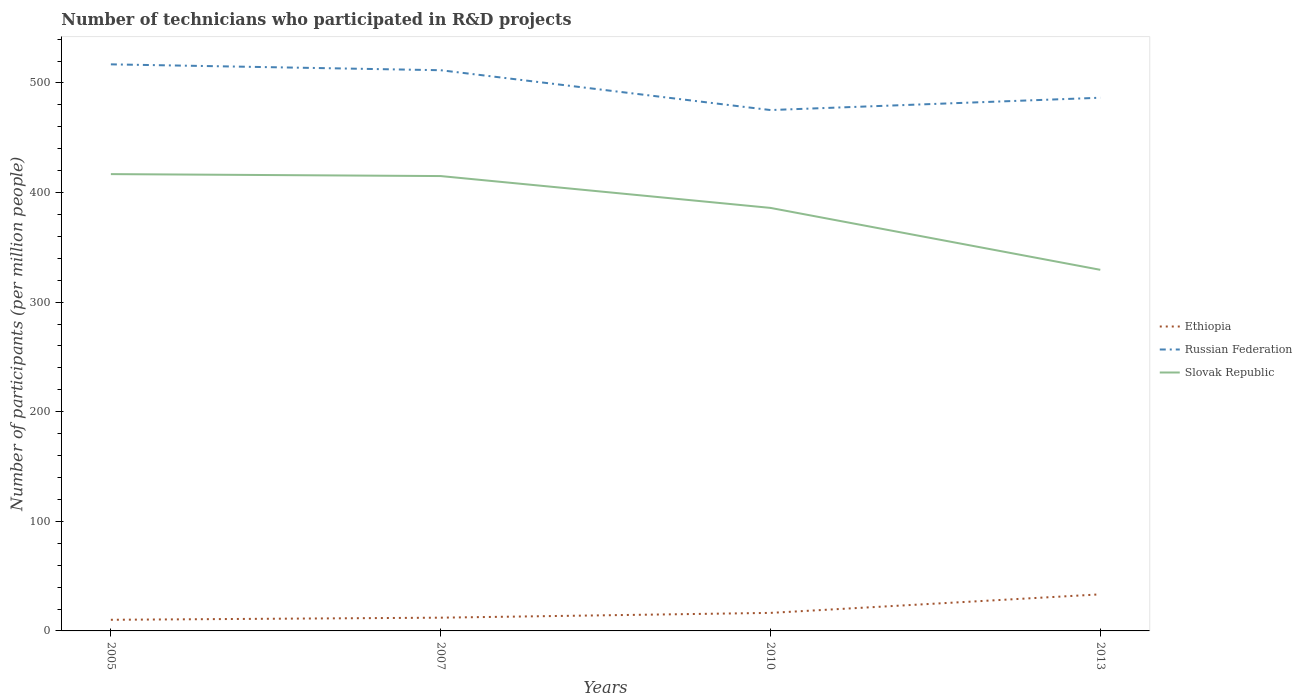Does the line corresponding to Ethiopia intersect with the line corresponding to Russian Federation?
Offer a terse response. No. Across all years, what is the maximum number of technicians who participated in R&D projects in Russian Federation?
Give a very brief answer. 475.29. In which year was the number of technicians who participated in R&D projects in Ethiopia maximum?
Give a very brief answer. 2005. What is the total number of technicians who participated in R&D projects in Slovak Republic in the graph?
Provide a succinct answer. 29.05. What is the difference between the highest and the second highest number of technicians who participated in R&D projects in Ethiopia?
Offer a very short reply. 23.21. What is the difference between the highest and the lowest number of technicians who participated in R&D projects in Slovak Republic?
Give a very brief answer. 2. Is the number of technicians who participated in R&D projects in Ethiopia strictly greater than the number of technicians who participated in R&D projects in Russian Federation over the years?
Ensure brevity in your answer.  Yes. How many lines are there?
Your response must be concise. 3. Where does the legend appear in the graph?
Offer a very short reply. Center right. How are the legend labels stacked?
Your answer should be very brief. Vertical. What is the title of the graph?
Your answer should be compact. Number of technicians who participated in R&D projects. What is the label or title of the X-axis?
Your response must be concise. Years. What is the label or title of the Y-axis?
Offer a very short reply. Number of participants (per million people). What is the Number of participants (per million people) of Ethiopia in 2005?
Provide a short and direct response. 10.17. What is the Number of participants (per million people) in Russian Federation in 2005?
Provide a short and direct response. 517. What is the Number of participants (per million people) in Slovak Republic in 2005?
Provide a succinct answer. 416.85. What is the Number of participants (per million people) of Ethiopia in 2007?
Provide a short and direct response. 12.09. What is the Number of participants (per million people) in Russian Federation in 2007?
Provide a short and direct response. 511.64. What is the Number of participants (per million people) in Slovak Republic in 2007?
Offer a terse response. 415.06. What is the Number of participants (per million people) of Ethiopia in 2010?
Offer a terse response. 16.46. What is the Number of participants (per million people) in Russian Federation in 2010?
Your response must be concise. 475.29. What is the Number of participants (per million people) in Slovak Republic in 2010?
Your answer should be very brief. 386.01. What is the Number of participants (per million people) in Ethiopia in 2013?
Provide a succinct answer. 33.38. What is the Number of participants (per million people) in Russian Federation in 2013?
Make the answer very short. 486.54. What is the Number of participants (per million people) in Slovak Republic in 2013?
Make the answer very short. 329.51. Across all years, what is the maximum Number of participants (per million people) of Ethiopia?
Provide a short and direct response. 33.38. Across all years, what is the maximum Number of participants (per million people) of Russian Federation?
Ensure brevity in your answer.  517. Across all years, what is the maximum Number of participants (per million people) of Slovak Republic?
Your answer should be compact. 416.85. Across all years, what is the minimum Number of participants (per million people) of Ethiopia?
Give a very brief answer. 10.17. Across all years, what is the minimum Number of participants (per million people) in Russian Federation?
Your answer should be compact. 475.29. Across all years, what is the minimum Number of participants (per million people) of Slovak Republic?
Your answer should be compact. 329.51. What is the total Number of participants (per million people) of Ethiopia in the graph?
Make the answer very short. 72.1. What is the total Number of participants (per million people) of Russian Federation in the graph?
Make the answer very short. 1990.48. What is the total Number of participants (per million people) in Slovak Republic in the graph?
Your answer should be compact. 1547.42. What is the difference between the Number of participants (per million people) in Ethiopia in 2005 and that in 2007?
Ensure brevity in your answer.  -1.92. What is the difference between the Number of participants (per million people) in Russian Federation in 2005 and that in 2007?
Your answer should be compact. 5.36. What is the difference between the Number of participants (per million people) in Slovak Republic in 2005 and that in 2007?
Your answer should be compact. 1.79. What is the difference between the Number of participants (per million people) in Ethiopia in 2005 and that in 2010?
Provide a succinct answer. -6.29. What is the difference between the Number of participants (per million people) of Russian Federation in 2005 and that in 2010?
Offer a terse response. 41.71. What is the difference between the Number of participants (per million people) of Slovak Republic in 2005 and that in 2010?
Make the answer very short. 30.84. What is the difference between the Number of participants (per million people) in Ethiopia in 2005 and that in 2013?
Give a very brief answer. -23.21. What is the difference between the Number of participants (per million people) in Russian Federation in 2005 and that in 2013?
Your answer should be compact. 30.46. What is the difference between the Number of participants (per million people) in Slovak Republic in 2005 and that in 2013?
Offer a very short reply. 87.34. What is the difference between the Number of participants (per million people) in Ethiopia in 2007 and that in 2010?
Your response must be concise. -4.37. What is the difference between the Number of participants (per million people) of Russian Federation in 2007 and that in 2010?
Make the answer very short. 36.35. What is the difference between the Number of participants (per million people) in Slovak Republic in 2007 and that in 2010?
Your response must be concise. 29.05. What is the difference between the Number of participants (per million people) in Ethiopia in 2007 and that in 2013?
Ensure brevity in your answer.  -21.29. What is the difference between the Number of participants (per million people) of Russian Federation in 2007 and that in 2013?
Your response must be concise. 25.1. What is the difference between the Number of participants (per million people) of Slovak Republic in 2007 and that in 2013?
Make the answer very short. 85.55. What is the difference between the Number of participants (per million people) in Ethiopia in 2010 and that in 2013?
Keep it short and to the point. -16.93. What is the difference between the Number of participants (per million people) in Russian Federation in 2010 and that in 2013?
Ensure brevity in your answer.  -11.25. What is the difference between the Number of participants (per million people) of Slovak Republic in 2010 and that in 2013?
Provide a short and direct response. 56.5. What is the difference between the Number of participants (per million people) of Ethiopia in 2005 and the Number of participants (per million people) of Russian Federation in 2007?
Your answer should be very brief. -501.47. What is the difference between the Number of participants (per million people) in Ethiopia in 2005 and the Number of participants (per million people) in Slovak Republic in 2007?
Offer a very short reply. -404.89. What is the difference between the Number of participants (per million people) of Russian Federation in 2005 and the Number of participants (per million people) of Slovak Republic in 2007?
Your response must be concise. 101.94. What is the difference between the Number of participants (per million people) in Ethiopia in 2005 and the Number of participants (per million people) in Russian Federation in 2010?
Provide a short and direct response. -465.12. What is the difference between the Number of participants (per million people) in Ethiopia in 2005 and the Number of participants (per million people) in Slovak Republic in 2010?
Your answer should be compact. -375.84. What is the difference between the Number of participants (per million people) of Russian Federation in 2005 and the Number of participants (per million people) of Slovak Republic in 2010?
Provide a short and direct response. 130.99. What is the difference between the Number of participants (per million people) of Ethiopia in 2005 and the Number of participants (per million people) of Russian Federation in 2013?
Provide a succinct answer. -476.37. What is the difference between the Number of participants (per million people) of Ethiopia in 2005 and the Number of participants (per million people) of Slovak Republic in 2013?
Offer a terse response. -319.34. What is the difference between the Number of participants (per million people) in Russian Federation in 2005 and the Number of participants (per million people) in Slovak Republic in 2013?
Offer a very short reply. 187.49. What is the difference between the Number of participants (per million people) in Ethiopia in 2007 and the Number of participants (per million people) in Russian Federation in 2010?
Your answer should be compact. -463.2. What is the difference between the Number of participants (per million people) of Ethiopia in 2007 and the Number of participants (per million people) of Slovak Republic in 2010?
Offer a terse response. -373.92. What is the difference between the Number of participants (per million people) in Russian Federation in 2007 and the Number of participants (per million people) in Slovak Republic in 2010?
Make the answer very short. 125.63. What is the difference between the Number of participants (per million people) in Ethiopia in 2007 and the Number of participants (per million people) in Russian Federation in 2013?
Ensure brevity in your answer.  -474.45. What is the difference between the Number of participants (per million people) of Ethiopia in 2007 and the Number of participants (per million people) of Slovak Republic in 2013?
Ensure brevity in your answer.  -317.42. What is the difference between the Number of participants (per million people) of Russian Federation in 2007 and the Number of participants (per million people) of Slovak Republic in 2013?
Keep it short and to the point. 182.13. What is the difference between the Number of participants (per million people) in Ethiopia in 2010 and the Number of participants (per million people) in Russian Federation in 2013?
Provide a short and direct response. -470.08. What is the difference between the Number of participants (per million people) of Ethiopia in 2010 and the Number of participants (per million people) of Slovak Republic in 2013?
Keep it short and to the point. -313.05. What is the difference between the Number of participants (per million people) of Russian Federation in 2010 and the Number of participants (per million people) of Slovak Republic in 2013?
Provide a succinct answer. 145.78. What is the average Number of participants (per million people) in Ethiopia per year?
Provide a short and direct response. 18.02. What is the average Number of participants (per million people) in Russian Federation per year?
Offer a terse response. 497.62. What is the average Number of participants (per million people) in Slovak Republic per year?
Keep it short and to the point. 386.86. In the year 2005, what is the difference between the Number of participants (per million people) in Ethiopia and Number of participants (per million people) in Russian Federation?
Give a very brief answer. -506.83. In the year 2005, what is the difference between the Number of participants (per million people) in Ethiopia and Number of participants (per million people) in Slovak Republic?
Keep it short and to the point. -406.68. In the year 2005, what is the difference between the Number of participants (per million people) of Russian Federation and Number of participants (per million people) of Slovak Republic?
Offer a very short reply. 100.15. In the year 2007, what is the difference between the Number of participants (per million people) of Ethiopia and Number of participants (per million people) of Russian Federation?
Give a very brief answer. -499.55. In the year 2007, what is the difference between the Number of participants (per million people) of Ethiopia and Number of participants (per million people) of Slovak Republic?
Make the answer very short. -402.97. In the year 2007, what is the difference between the Number of participants (per million people) in Russian Federation and Number of participants (per million people) in Slovak Republic?
Ensure brevity in your answer.  96.58. In the year 2010, what is the difference between the Number of participants (per million people) of Ethiopia and Number of participants (per million people) of Russian Federation?
Keep it short and to the point. -458.84. In the year 2010, what is the difference between the Number of participants (per million people) in Ethiopia and Number of participants (per million people) in Slovak Republic?
Offer a very short reply. -369.55. In the year 2010, what is the difference between the Number of participants (per million people) of Russian Federation and Number of participants (per million people) of Slovak Republic?
Offer a very short reply. 89.29. In the year 2013, what is the difference between the Number of participants (per million people) of Ethiopia and Number of participants (per million people) of Russian Federation?
Keep it short and to the point. -453.16. In the year 2013, what is the difference between the Number of participants (per million people) in Ethiopia and Number of participants (per million people) in Slovak Republic?
Offer a very short reply. -296.13. In the year 2013, what is the difference between the Number of participants (per million people) in Russian Federation and Number of participants (per million people) in Slovak Republic?
Ensure brevity in your answer.  157.03. What is the ratio of the Number of participants (per million people) in Ethiopia in 2005 to that in 2007?
Give a very brief answer. 0.84. What is the ratio of the Number of participants (per million people) in Russian Federation in 2005 to that in 2007?
Your answer should be compact. 1.01. What is the ratio of the Number of participants (per million people) of Ethiopia in 2005 to that in 2010?
Give a very brief answer. 0.62. What is the ratio of the Number of participants (per million people) of Russian Federation in 2005 to that in 2010?
Ensure brevity in your answer.  1.09. What is the ratio of the Number of participants (per million people) in Slovak Republic in 2005 to that in 2010?
Offer a very short reply. 1.08. What is the ratio of the Number of participants (per million people) in Ethiopia in 2005 to that in 2013?
Provide a succinct answer. 0.3. What is the ratio of the Number of participants (per million people) of Russian Federation in 2005 to that in 2013?
Your answer should be compact. 1.06. What is the ratio of the Number of participants (per million people) of Slovak Republic in 2005 to that in 2013?
Ensure brevity in your answer.  1.27. What is the ratio of the Number of participants (per million people) in Ethiopia in 2007 to that in 2010?
Your answer should be compact. 0.73. What is the ratio of the Number of participants (per million people) in Russian Federation in 2007 to that in 2010?
Provide a short and direct response. 1.08. What is the ratio of the Number of participants (per million people) of Slovak Republic in 2007 to that in 2010?
Offer a terse response. 1.08. What is the ratio of the Number of participants (per million people) in Ethiopia in 2007 to that in 2013?
Provide a succinct answer. 0.36. What is the ratio of the Number of participants (per million people) of Russian Federation in 2007 to that in 2013?
Offer a terse response. 1.05. What is the ratio of the Number of participants (per million people) of Slovak Republic in 2007 to that in 2013?
Your response must be concise. 1.26. What is the ratio of the Number of participants (per million people) of Ethiopia in 2010 to that in 2013?
Provide a short and direct response. 0.49. What is the ratio of the Number of participants (per million people) of Russian Federation in 2010 to that in 2013?
Offer a terse response. 0.98. What is the ratio of the Number of participants (per million people) in Slovak Republic in 2010 to that in 2013?
Provide a succinct answer. 1.17. What is the difference between the highest and the second highest Number of participants (per million people) in Ethiopia?
Provide a short and direct response. 16.93. What is the difference between the highest and the second highest Number of participants (per million people) of Russian Federation?
Offer a terse response. 5.36. What is the difference between the highest and the second highest Number of participants (per million people) of Slovak Republic?
Ensure brevity in your answer.  1.79. What is the difference between the highest and the lowest Number of participants (per million people) of Ethiopia?
Make the answer very short. 23.21. What is the difference between the highest and the lowest Number of participants (per million people) in Russian Federation?
Keep it short and to the point. 41.71. What is the difference between the highest and the lowest Number of participants (per million people) in Slovak Republic?
Offer a terse response. 87.34. 